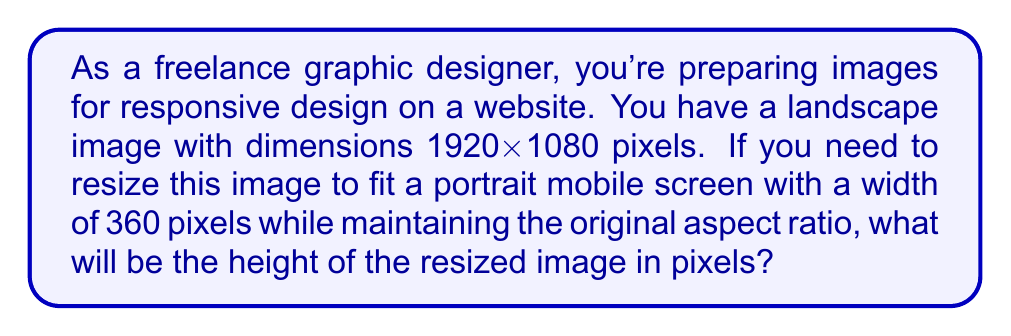What is the answer to this math problem? Let's approach this step-by-step:

1) First, we need to calculate the aspect ratio of the original image:
   $$ \text{Aspect Ratio} = \frac{\text{Width}}{\text{Height}} = \frac{1920}{1080} = \frac{16}{9} $$

2) The aspect ratio must remain constant when resizing. We can express this as an equation:
   $$ \frac{1920}{1080} = \frac{360}{x} $$
   where $x$ is the unknown height of the resized image.

3) Cross multiply to solve for $x$:
   $$ 1920x = 1080 \cdot 360 $$

4) Simplify the right side:
   $$ 1920x = 388800 $$

5) Divide both sides by 1920:
   $$ x = \frac{388800}{1920} = 202.5 $$

6) Since we can't have fractional pixels, we round to the nearest whole number:
   $$ x \approx 203 \text{ pixels} $$

Therefore, the height of the resized image will be 203 pixels.
Answer: 203 pixels 